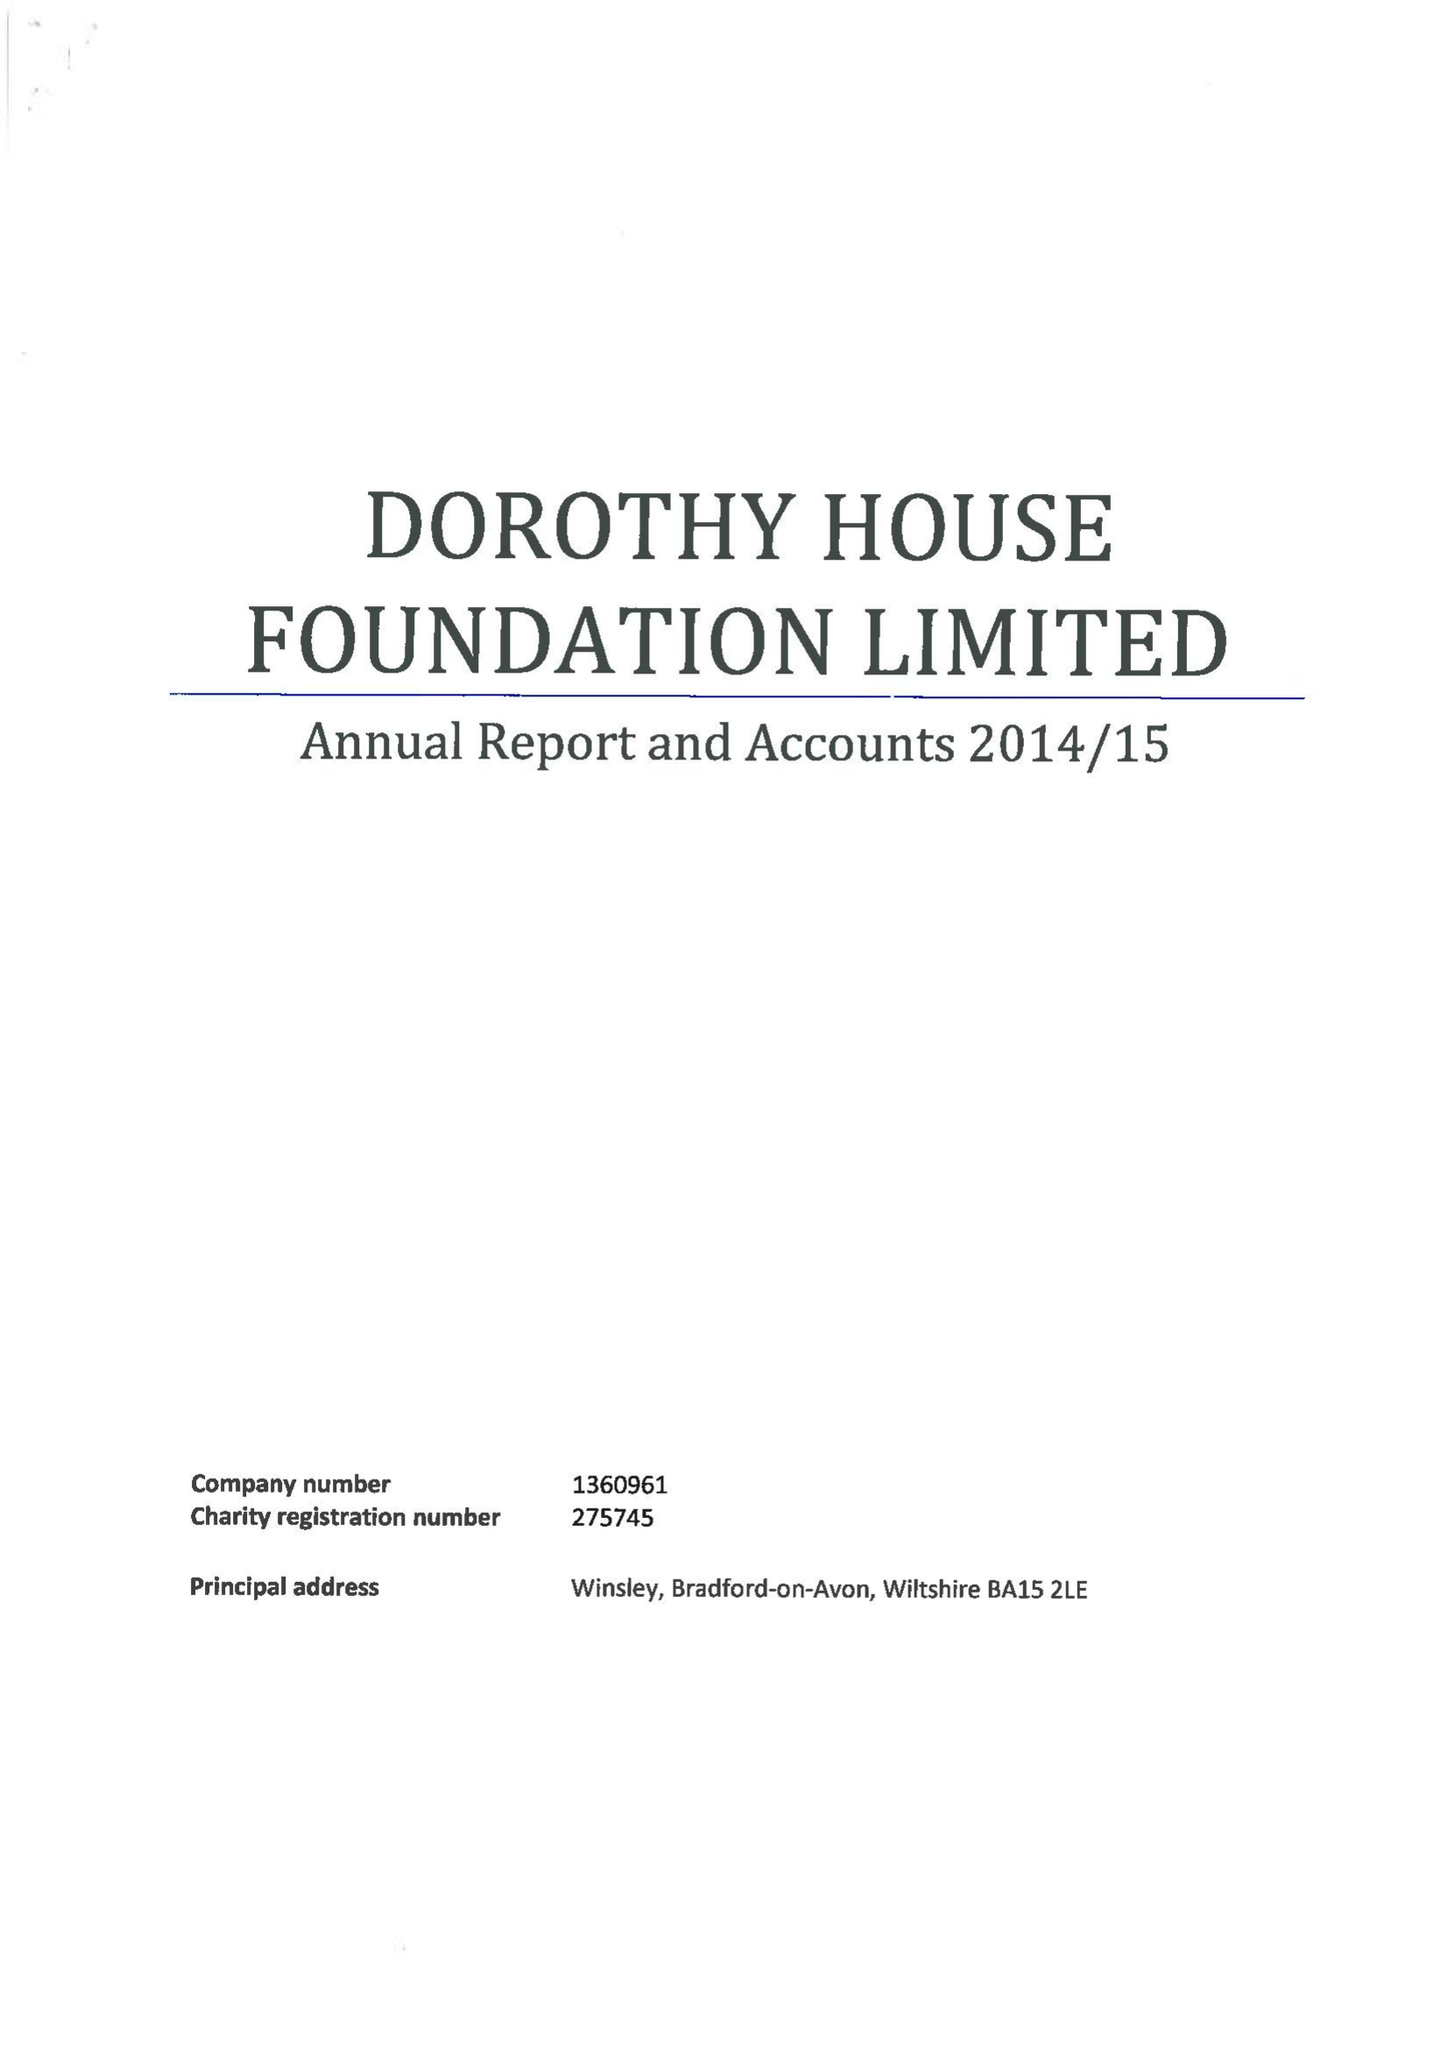What is the value for the income_annually_in_british_pounds?
Answer the question using a single word or phrase. 10782371.00 